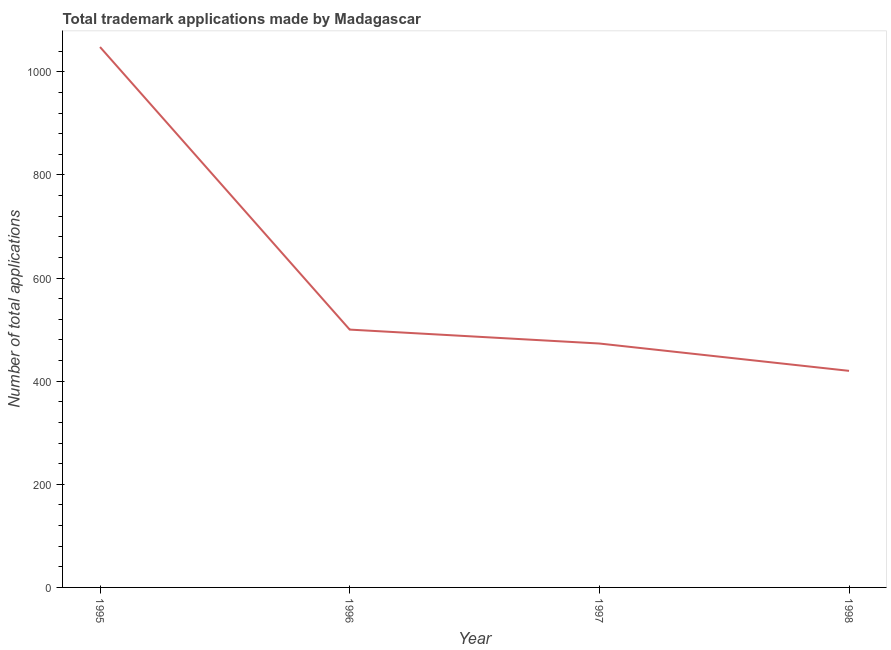What is the number of trademark applications in 1996?
Keep it short and to the point. 500. Across all years, what is the maximum number of trademark applications?
Offer a very short reply. 1048. Across all years, what is the minimum number of trademark applications?
Provide a succinct answer. 420. What is the sum of the number of trademark applications?
Ensure brevity in your answer.  2441. What is the difference between the number of trademark applications in 1996 and 1998?
Make the answer very short. 80. What is the average number of trademark applications per year?
Provide a short and direct response. 610.25. What is the median number of trademark applications?
Make the answer very short. 486.5. In how many years, is the number of trademark applications greater than 960 ?
Your answer should be compact. 1. Do a majority of the years between 1995 and 1997 (inclusive) have number of trademark applications greater than 920 ?
Make the answer very short. No. What is the ratio of the number of trademark applications in 1997 to that in 1998?
Give a very brief answer. 1.13. Is the number of trademark applications in 1995 less than that in 1997?
Your answer should be very brief. No. What is the difference between the highest and the second highest number of trademark applications?
Provide a succinct answer. 548. What is the difference between the highest and the lowest number of trademark applications?
Your answer should be very brief. 628. In how many years, is the number of trademark applications greater than the average number of trademark applications taken over all years?
Offer a terse response. 1. How many lines are there?
Your answer should be very brief. 1. How many years are there in the graph?
Offer a very short reply. 4. What is the difference between two consecutive major ticks on the Y-axis?
Provide a short and direct response. 200. Does the graph contain any zero values?
Provide a succinct answer. No. Does the graph contain grids?
Your answer should be compact. No. What is the title of the graph?
Offer a very short reply. Total trademark applications made by Madagascar. What is the label or title of the Y-axis?
Your response must be concise. Number of total applications. What is the Number of total applications of 1995?
Your answer should be compact. 1048. What is the Number of total applications in 1997?
Your answer should be compact. 473. What is the Number of total applications of 1998?
Ensure brevity in your answer.  420. What is the difference between the Number of total applications in 1995 and 1996?
Ensure brevity in your answer.  548. What is the difference between the Number of total applications in 1995 and 1997?
Make the answer very short. 575. What is the difference between the Number of total applications in 1995 and 1998?
Provide a short and direct response. 628. What is the difference between the Number of total applications in 1996 and 1997?
Your answer should be very brief. 27. What is the ratio of the Number of total applications in 1995 to that in 1996?
Keep it short and to the point. 2.1. What is the ratio of the Number of total applications in 1995 to that in 1997?
Your response must be concise. 2.22. What is the ratio of the Number of total applications in 1995 to that in 1998?
Provide a succinct answer. 2.5. What is the ratio of the Number of total applications in 1996 to that in 1997?
Offer a terse response. 1.06. What is the ratio of the Number of total applications in 1996 to that in 1998?
Your answer should be very brief. 1.19. What is the ratio of the Number of total applications in 1997 to that in 1998?
Your response must be concise. 1.13. 